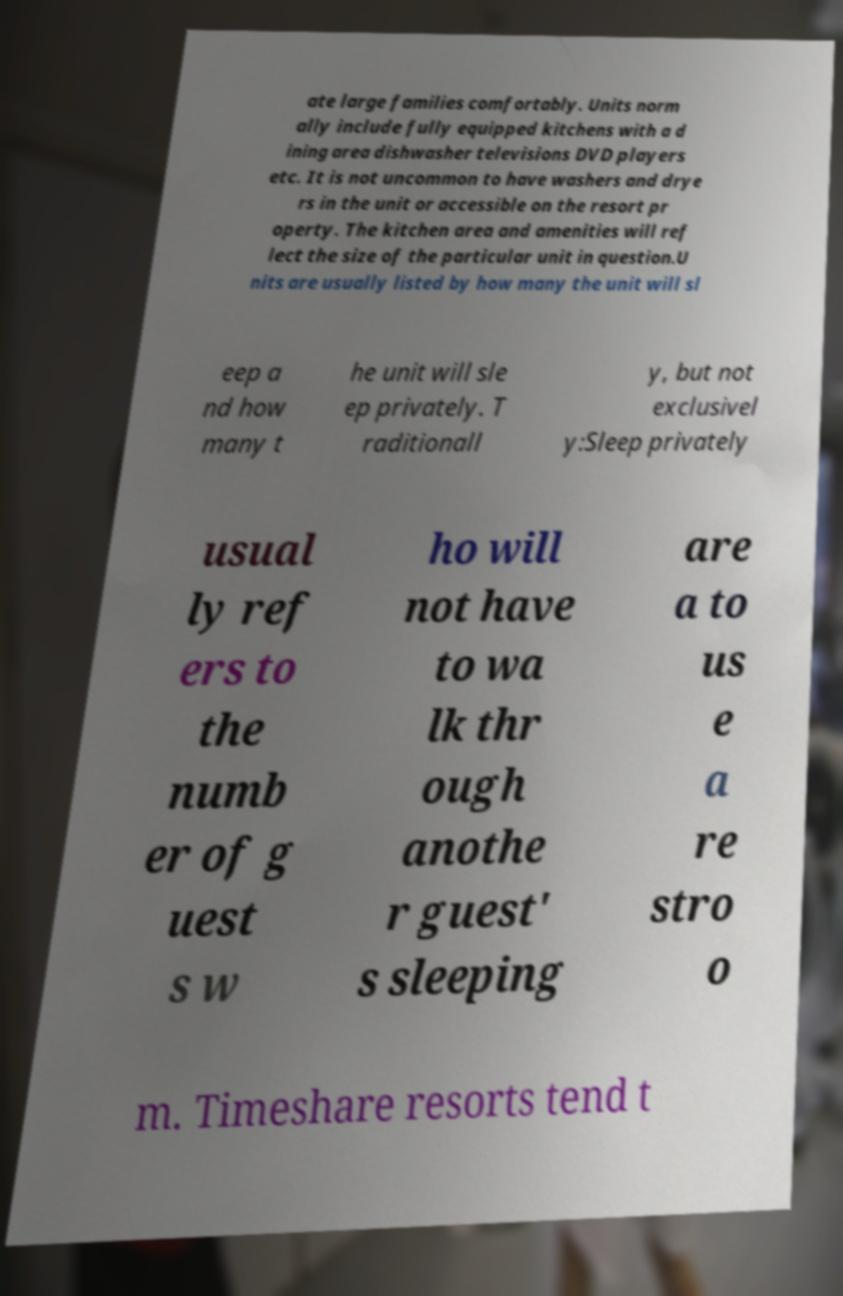For documentation purposes, I need the text within this image transcribed. Could you provide that? ate large families comfortably. Units norm ally include fully equipped kitchens with a d ining area dishwasher televisions DVD players etc. It is not uncommon to have washers and drye rs in the unit or accessible on the resort pr operty. The kitchen area and amenities will ref lect the size of the particular unit in question.U nits are usually listed by how many the unit will sl eep a nd how many t he unit will sle ep privately. T raditionall y, but not exclusivel y:Sleep privately usual ly ref ers to the numb er of g uest s w ho will not have to wa lk thr ough anothe r guest' s sleeping are a to us e a re stro o m. Timeshare resorts tend t 